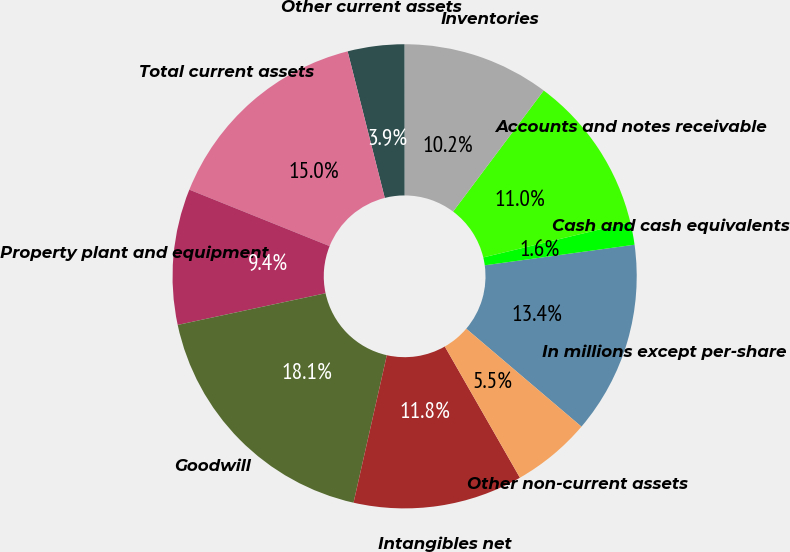Convert chart. <chart><loc_0><loc_0><loc_500><loc_500><pie_chart><fcel>In millions except per-share<fcel>Cash and cash equivalents<fcel>Accounts and notes receivable<fcel>Inventories<fcel>Other current assets<fcel>Total current assets<fcel>Property plant and equipment<fcel>Goodwill<fcel>Intangibles net<fcel>Other non-current assets<nl><fcel>13.39%<fcel>1.58%<fcel>11.02%<fcel>10.24%<fcel>3.94%<fcel>14.96%<fcel>9.45%<fcel>18.11%<fcel>11.81%<fcel>5.51%<nl></chart> 